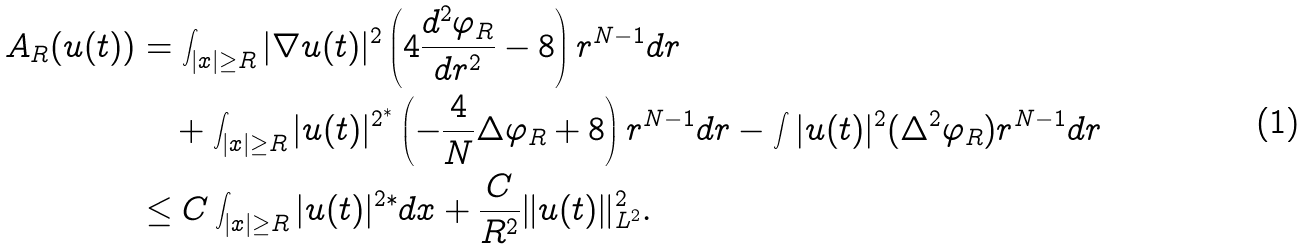<formula> <loc_0><loc_0><loc_500><loc_500>A _ { R } ( u ( t ) ) & = \int _ { | x | \geq R } | \nabla u ( t ) | ^ { 2 } \left ( 4 \frac { d ^ { 2 } \varphi _ { R } } { d r ^ { 2 } } - 8 \right ) r ^ { N - 1 } d r \\ & \quad + \int _ { | x | \geq R } | u ( t ) | ^ { 2 ^ { * } } \left ( - \frac { 4 } { N } \Delta \varphi _ { R } + 8 \right ) r ^ { N - 1 } d r - \int | u ( t ) | ^ { 2 } ( \Delta ^ { 2 } \varphi _ { R } ) r ^ { N - 1 } d r \\ & \leq C \int _ { | x | \geq R } | u ( t ) | ^ { 2 * } d x + \frac { C } { R ^ { 2 } } \| u ( t ) \| _ { L ^ { 2 } } ^ { 2 } .</formula> 